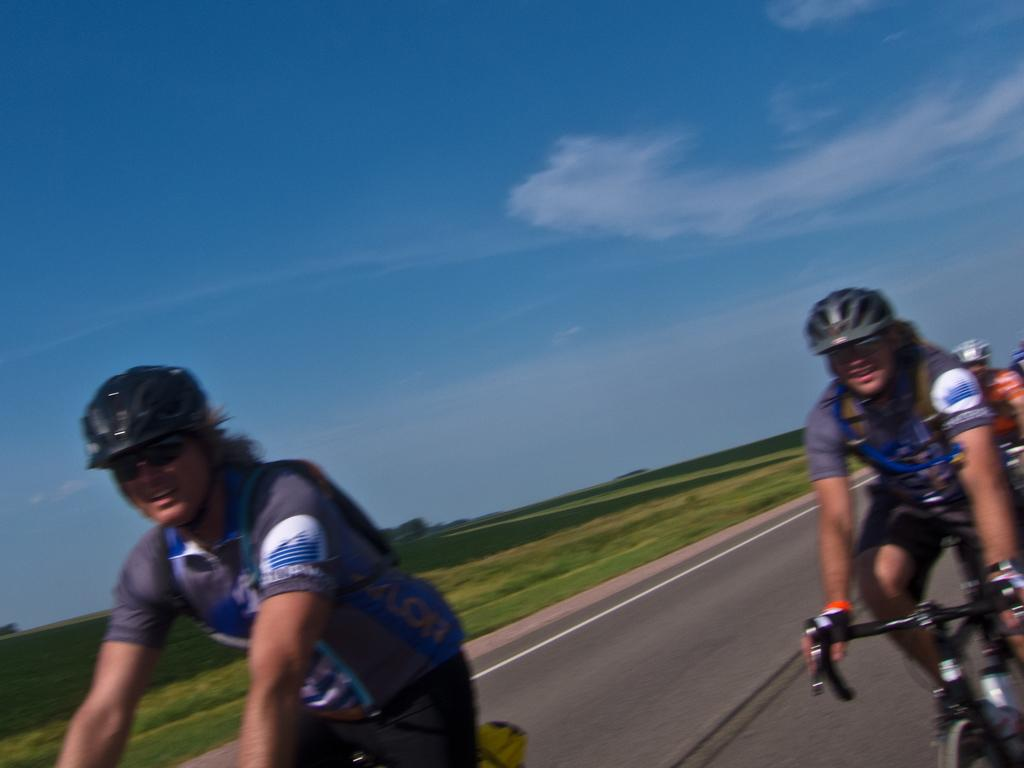What are the people in the image doing? The people in the image are riding bicycles. Where are the people riding their bicycles? The people are on the road. What else can be seen in the image besides the people and bicycles? There are plants visible in the image. How would you describe the weather based on the image? The sky is cloudy in the image, suggesting a potentially overcast or cloudy day. Where is the faucet located in the image? There is no faucet present in the image. How do the people riding bicycles maintain their grip on the handlebars? The image does not provide information about the people's grip on the handlebars, but it can be inferred that they are likely holding onto the handlebars to maintain control of their bicycles. 